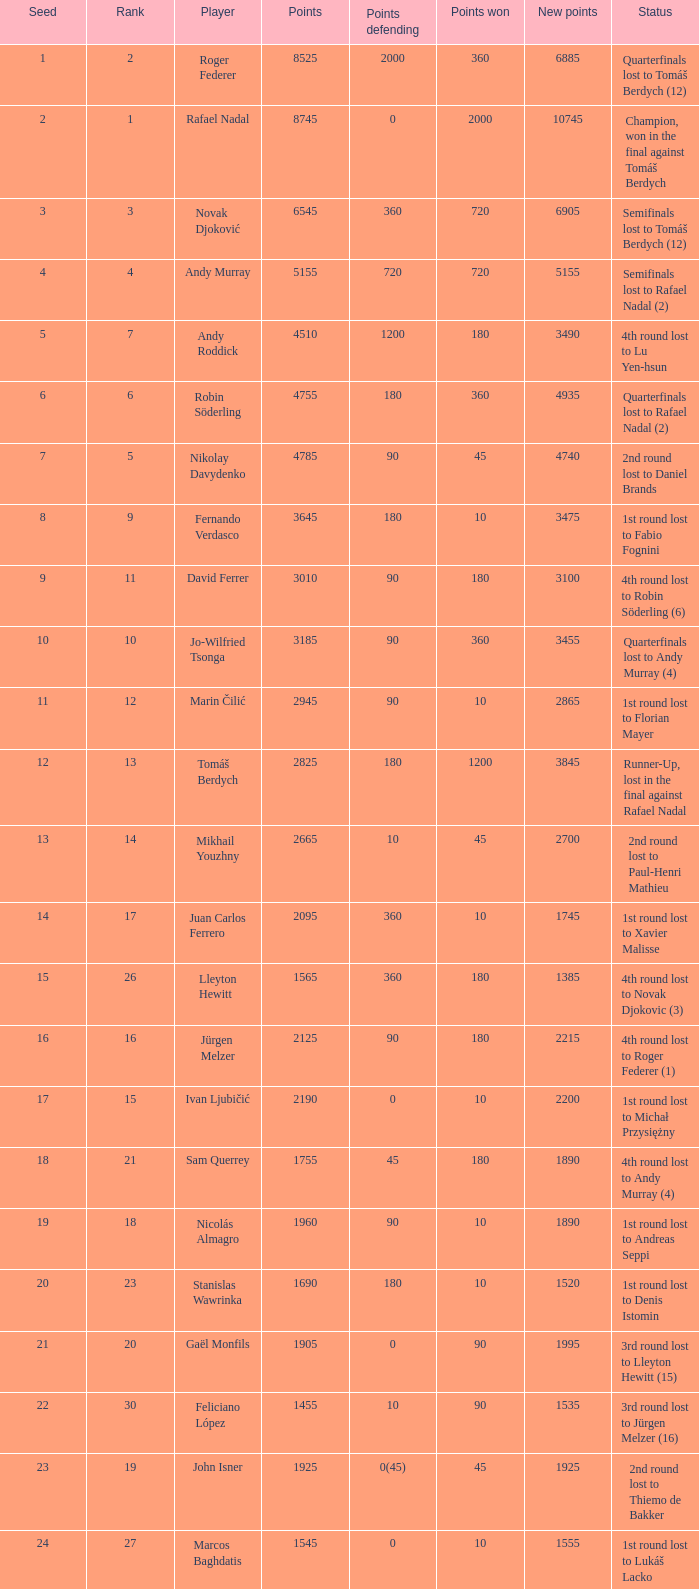Specify the points earned for 1230 90.0. 